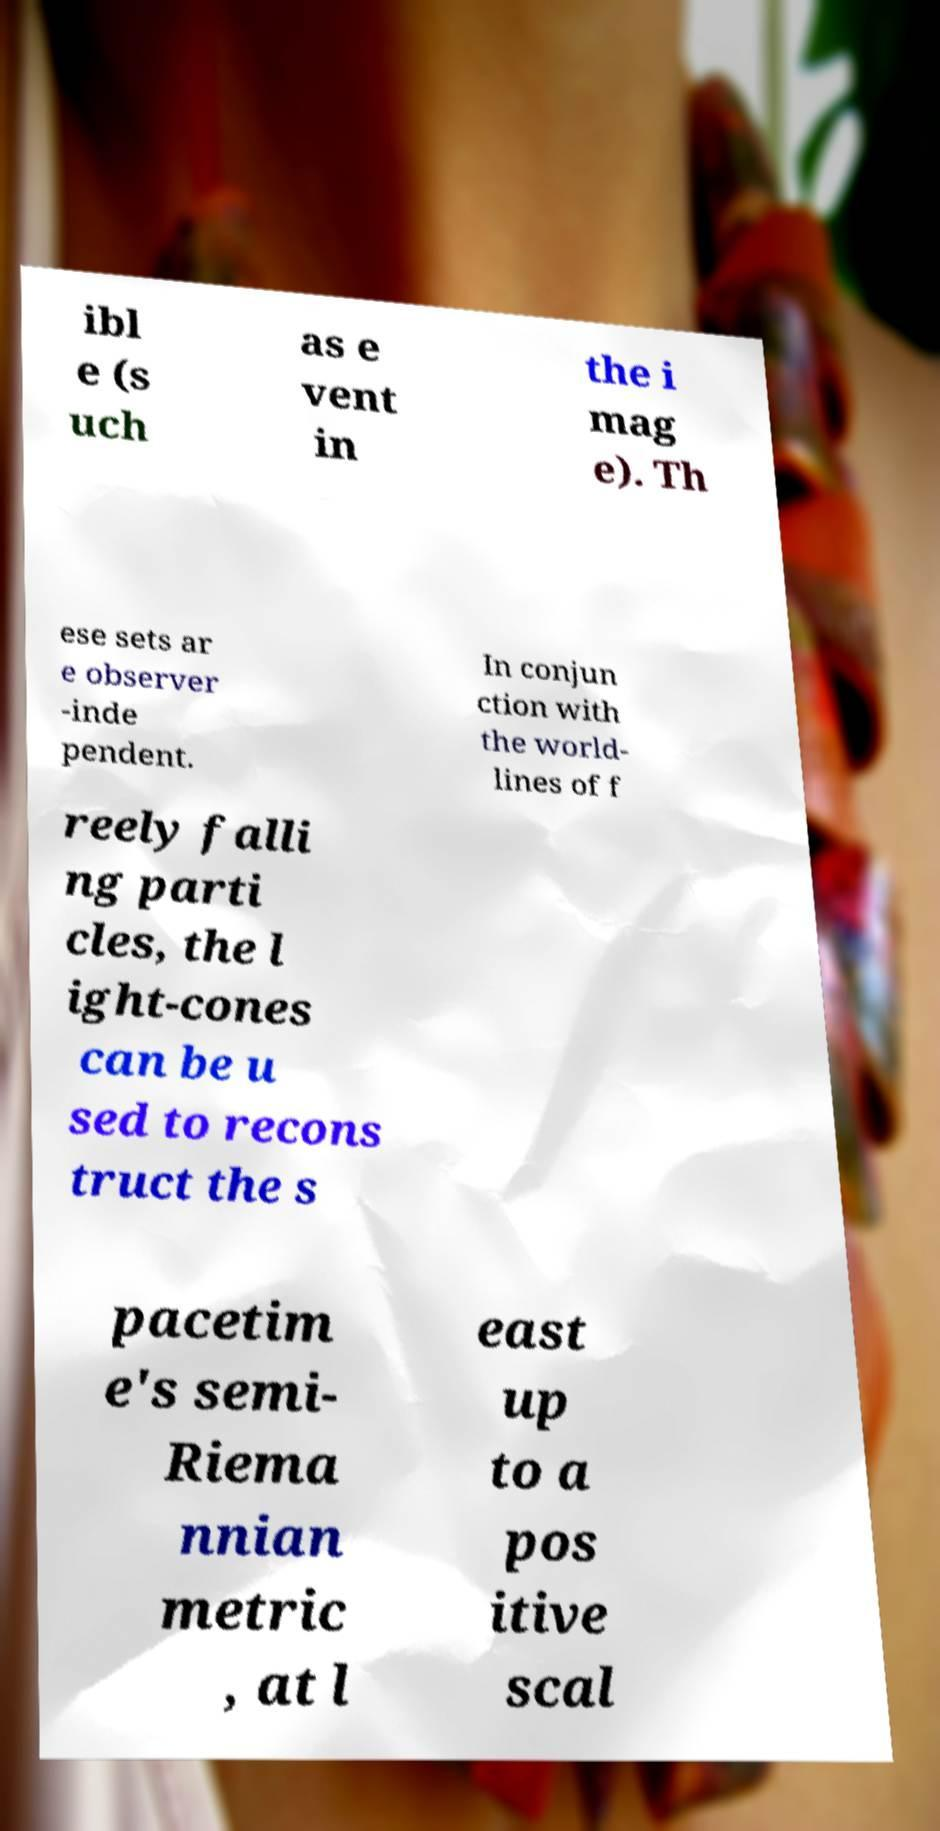Can you read and provide the text displayed in the image?This photo seems to have some interesting text. Can you extract and type it out for me? ibl e (s uch as e vent in the i mag e). Th ese sets ar e observer -inde pendent. In conjun ction with the world- lines of f reely falli ng parti cles, the l ight-cones can be u sed to recons truct the s pacetim e's semi- Riema nnian metric , at l east up to a pos itive scal 